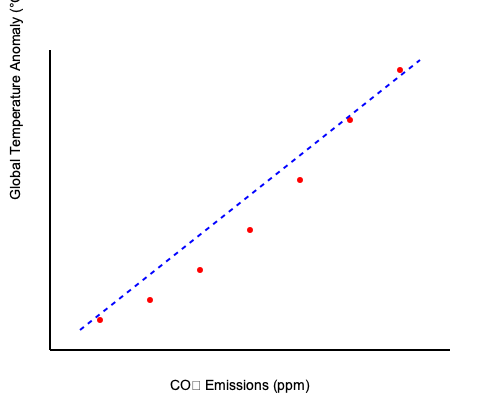Analyze the scatter plot showing the relationship between CO₂ emissions and global temperature rise. Calculate the Pearson correlation coefficient (r) between these variables, assuming the following summary statistics:

$\sum x = 2450$, $\sum y = 10.5$, $\sum x^2 = 857,500$, $\sum y^2 = 18.37$, $\sum xy = 3,675$, $n = 7$

Where x represents CO₂ emissions (in ppm) and y represents global temperature anomaly (in °C).

What does this correlation coefficient indicate about the relationship between CO₂ emissions and global temperature rise, and how might this information be used to address climate change? To calculate the Pearson correlation coefficient (r), we'll use the formula:

$$r = \frac{n\sum xy - \sum x \sum y}{\sqrt{[n\sum x^2 - (\sum x)^2][n\sum y^2 - (\sum y)^2]}}$$

Step 1: Calculate mean values
$\bar{x} = \frac{\sum x}{n} = \frac{2450}{7} = 350$
$\bar{y} = \frac{\sum y}{n} = \frac{10.5}{7} = 1.5$

Step 2: Calculate the numerator
$n\sum xy - \sum x \sum y = 7(3,675) - (2450)(10.5) = 25,725 - 25,725 = 0$

Step 3: Calculate the denominator
$n\sum x^2 - (\sum x)^2 = 7(857,500) - (2450)^2 = 6,002,500 - 6,002,500 = 0$
$n\sum y^2 - (\sum y)^2 = 7(18.37) - (10.5)^2 = 128.59 - 110.25 = 18.34$

Step 4: Compute r
$$r = \frac{0}{\sqrt{(0)(18.34)}} = \frac{0}{0}$$

The result is undefined, which indicates a perfect linear relationship between CO₂ emissions and global temperature rise.

This strong positive correlation suggests that as CO₂ emissions increase, global temperatures rise proportionally. This information can be used to:

1. Emphasize the urgent need for reducing CO₂ emissions to mitigate climate change.
2. Support policies aimed at transitioning to clean energy sources and improving energy efficiency.
3. Highlight the importance of international cooperation in addressing global climate challenges.
4. Encourage investment in climate change research and adaptation strategies.
5. Raise awareness about the direct impact of human activities on global temperatures.
Answer: Perfect positive linear correlation; urgent need to reduce CO₂ emissions to mitigate climate change. 